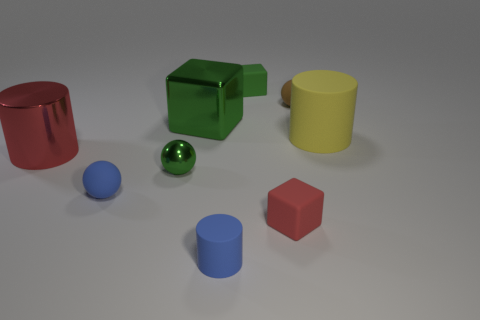Subtract all spheres. How many objects are left? 6 Subtract all large purple rubber spheres. Subtract all blue objects. How many objects are left? 7 Add 4 small blue spheres. How many small blue spheres are left? 5 Add 3 big cyan matte cylinders. How many big cyan matte cylinders exist? 3 Subtract 0 red spheres. How many objects are left? 9 